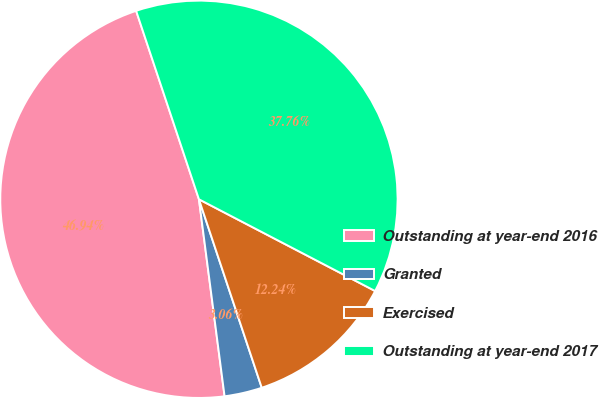Convert chart. <chart><loc_0><loc_0><loc_500><loc_500><pie_chart><fcel>Outstanding at year-end 2016<fcel>Granted<fcel>Exercised<fcel>Outstanding at year-end 2017<nl><fcel>46.94%<fcel>3.06%<fcel>12.24%<fcel>37.76%<nl></chart> 